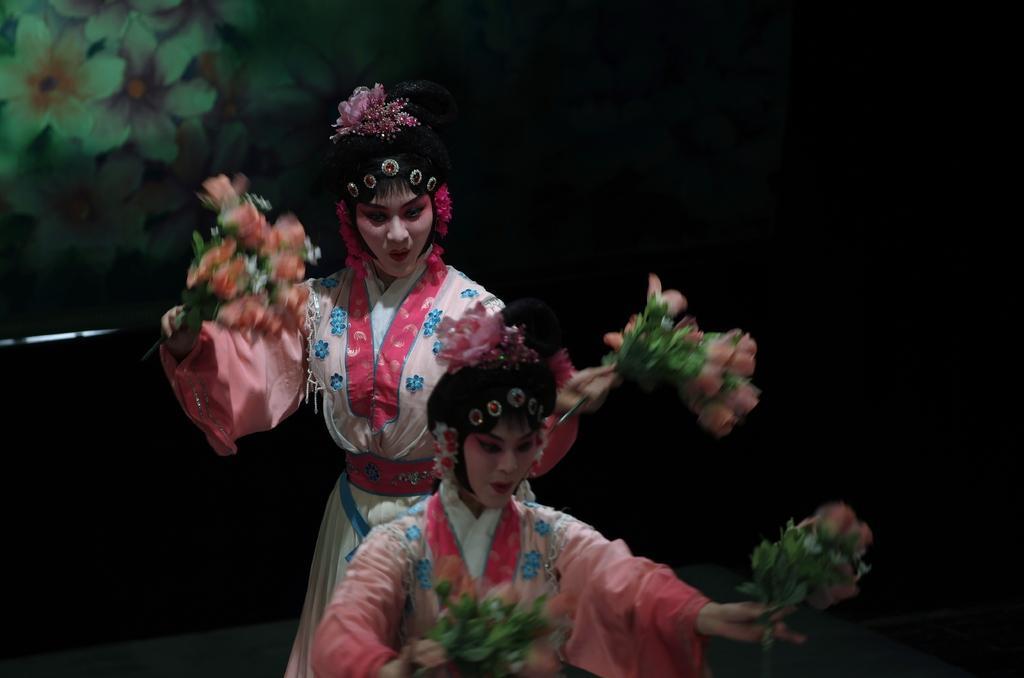Can you describe this image briefly? In the image there are two women who are dancing by holding a flower bouquet in their hands and on the top of the head there is a pink colour flower. 